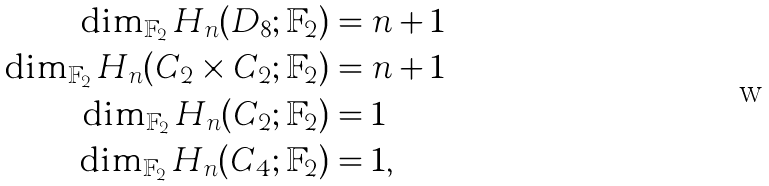Convert formula to latex. <formula><loc_0><loc_0><loc_500><loc_500>\dim _ { \mathbb { F } _ { 2 } } H _ { n } ( D _ { 8 } ; \mathbb { F } _ { 2 } ) & = n + 1 \\ \dim _ { \mathbb { F } _ { 2 } } H _ { n } ( C _ { 2 } \times C _ { 2 } ; \mathbb { F } _ { 2 } ) & = n + 1 \\ \dim _ { \mathbb { F } _ { 2 } } H _ { n } ( C _ { 2 } ; \mathbb { F } _ { 2 } ) & = 1 \\ \dim _ { \mathbb { F } _ { 2 } } H _ { n } ( C _ { 4 } ; \mathbb { F } _ { 2 } ) & = 1 ,</formula> 